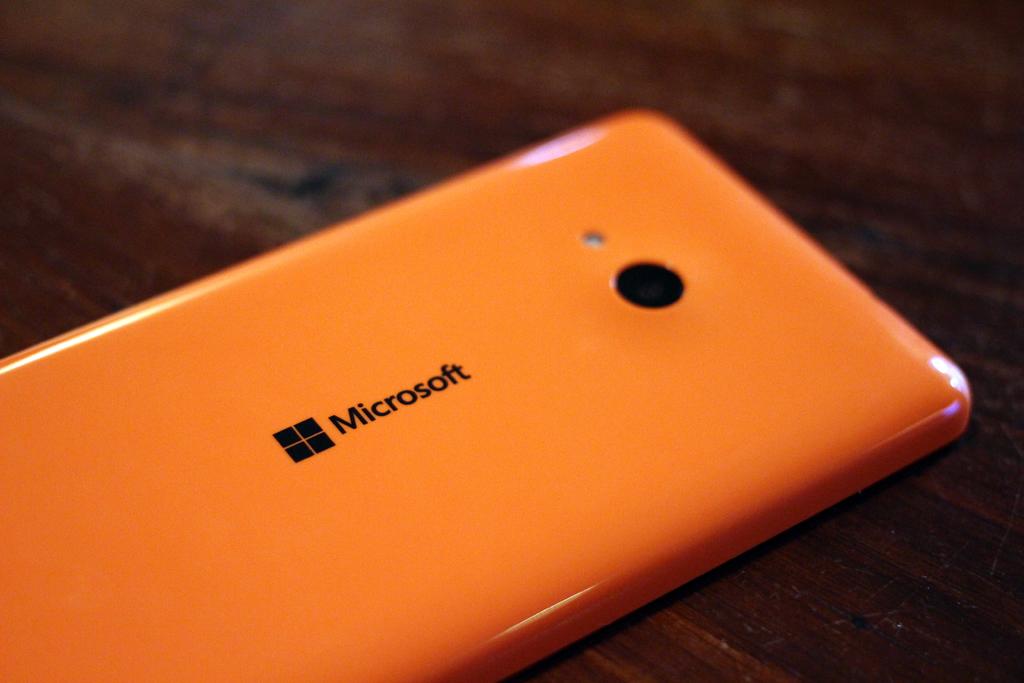What is the name on this device?
Provide a short and direct response. Microsoft. What brand of phone is this?
Give a very brief answer. Microsoft. 